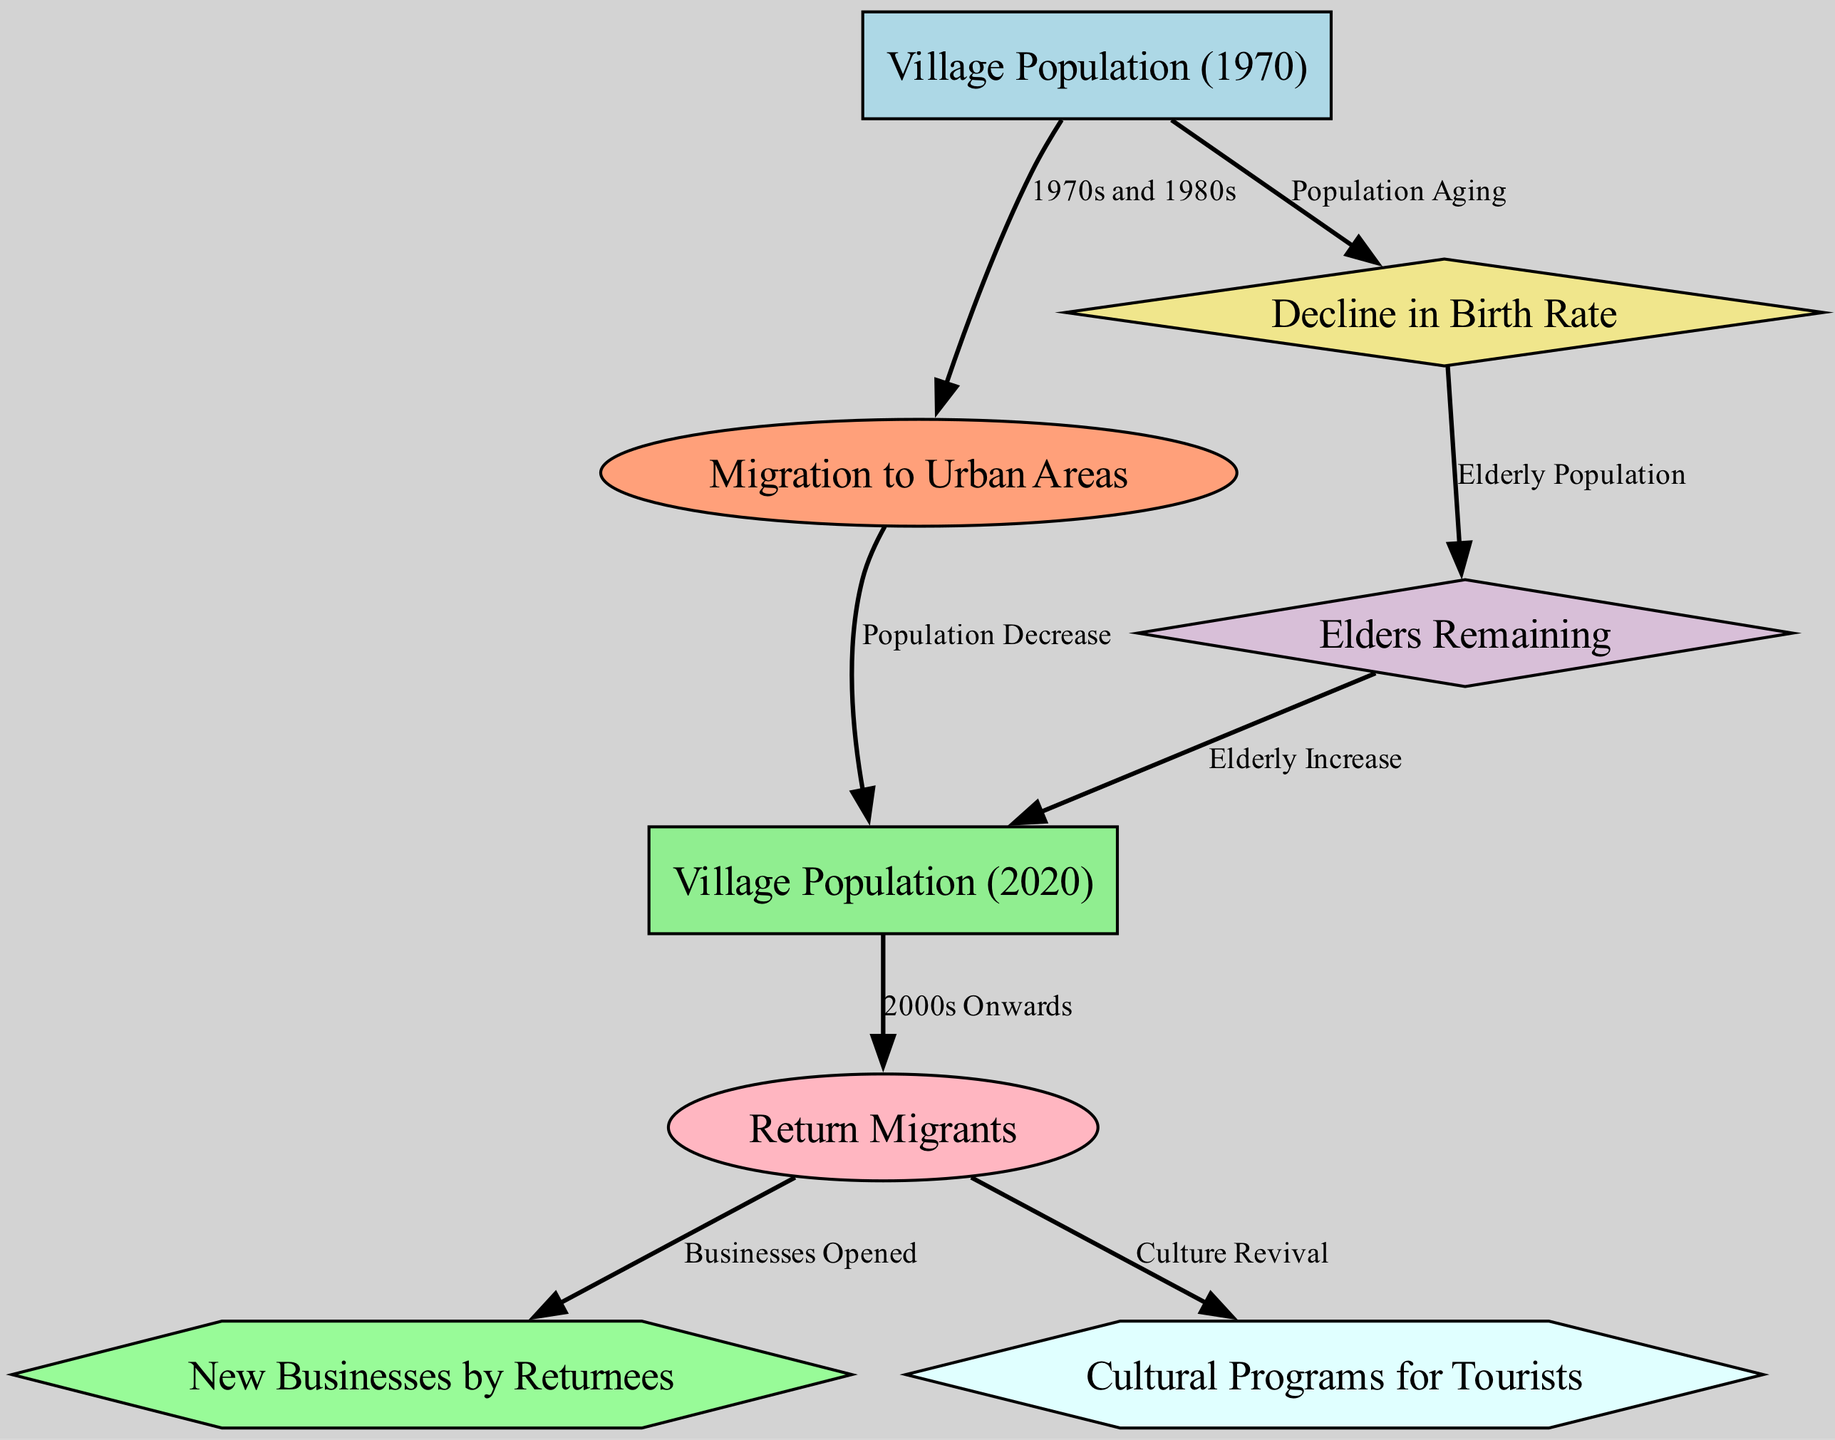What was the village population in 1970? The diagram includes a node labeled "Village Population (1970)" which represents the population size in that year. However, the exact number is not specified in the provided data.
Answer: Not specified What caused the population decrease from 1970 to 2020? The diagram shows an edge labeled "Population Decrease" that connects the "Migration to Urban Areas" node to the "Village Population (2020)" node, indicating that migration to cities led to a decrease in the village population.
Answer: Migration to Urban Areas What factor influenced the increase in return migrants after 2000? According to the diagram, the edge connecting "Village Population (2020)" to "Return Migrants" is labeled "2000s Onwards," indicating that demographic shifts in the village allowed for an increase in return migration during this period.
Answer: Demographic Shifts How does the decline in birth rate affect the elderly population? The diagram connects "Decline in Birth Rate" to "Elders Remaining" and further to "Village Population (2020)," indicating that as birth rates declined, the percentage of elderly in the population remained a significant factor, contributing to the aging village population over time.
Answer: Increased elderly population How many edges indicate cultural revival linked to return migrants? There are two edges stemming from the "Return Migrants" node, labeled as "Businesses Opened" and "Culture Revival," thus indicating that return migrants contribute to cultural revival through entrepreneurship and cultural programs.
Answer: Two edges What is the relationship between elders remaining and the village population in 2020? The edge labeled "Elderly Increase" connects "Elders Remaining" to "Village Population (2020)," suggesting that the increase in elderly individuals remains a significant aspect of the overall village population dynamics.
Answer: Increase in elderly population What business development occurred due to return migrants? The node "New Businesses by Returnees" is linked directly to the "Return Migrants" node with an edge labeled "Businesses Opened," indicating that the return of migrants has led to the establishment of new businesses in the village.
Answer: New Businesses What cultural initiatives were developed as a result of return migrants? An edge connects the "Return Migrants" node to the "Cultural Programs for Tourists" node, labeled "Culture Revival," indicating that returnees contributed to the development of cultural initiatives for tourists in the village.
Answer: Cultural Programs for Tourists What was the effect of population aging on the earlier population measures? The edge connecting "Village Population (1970)" to "Decline in Birth Rate" shows that aging populations and declining birth rates impacted the demographic structure and contributed to the overall analysis of population changes over time.
Answer: Impacted demographic structure How did the return migrants influence the economic landscape of the village? Return migrants are linked to "New Businesses by Returnees," indicating their influence in generating economic activities, which is essential for revitalizing the village's economy and opportunities for its residents.
Answer: New Businesses by Returnees 